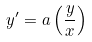<formula> <loc_0><loc_0><loc_500><loc_500>y ^ { \prime } = a \left ( \frac { y } { x } \right )</formula> 